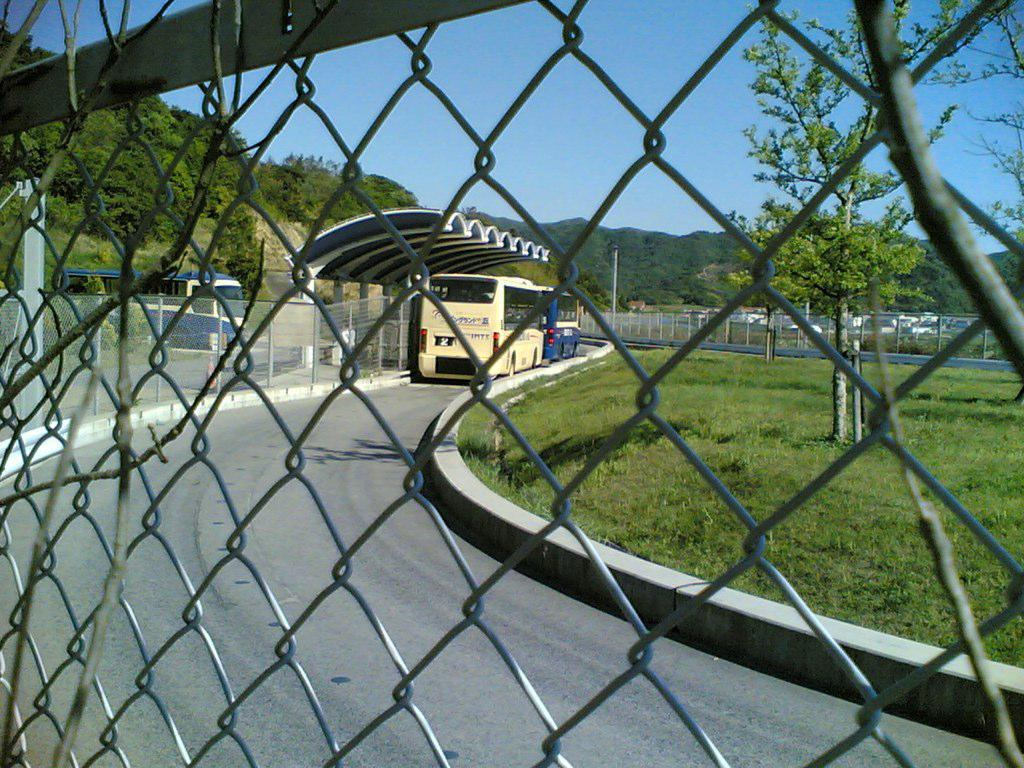What type of vehicles can be seen on the road in the image? There are buses on the road in the image. What structures are present in the image? There are fences, a shelter, and poles in the image. What type of vegetation is visible in the image? There is grass and trees in the image. What geographical feature can be seen in the background of the image? There are mountains in the image. What part of the natural environment is visible in the image? The sky is visible in the background of the image. How many cows can be seen grazing on the slope in the image? There are no cows or slopes present in the image. What level of difficulty is the hiking trail in the image? There is no hiking trail mentioned in the image, so it is not possible to determine its level of difficulty. 